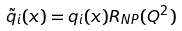<formula> <loc_0><loc_0><loc_500><loc_500>\tilde { q } _ { i } ( x ) = q _ { i } ( x ) R _ { N P } ( Q ^ { 2 } )</formula> 